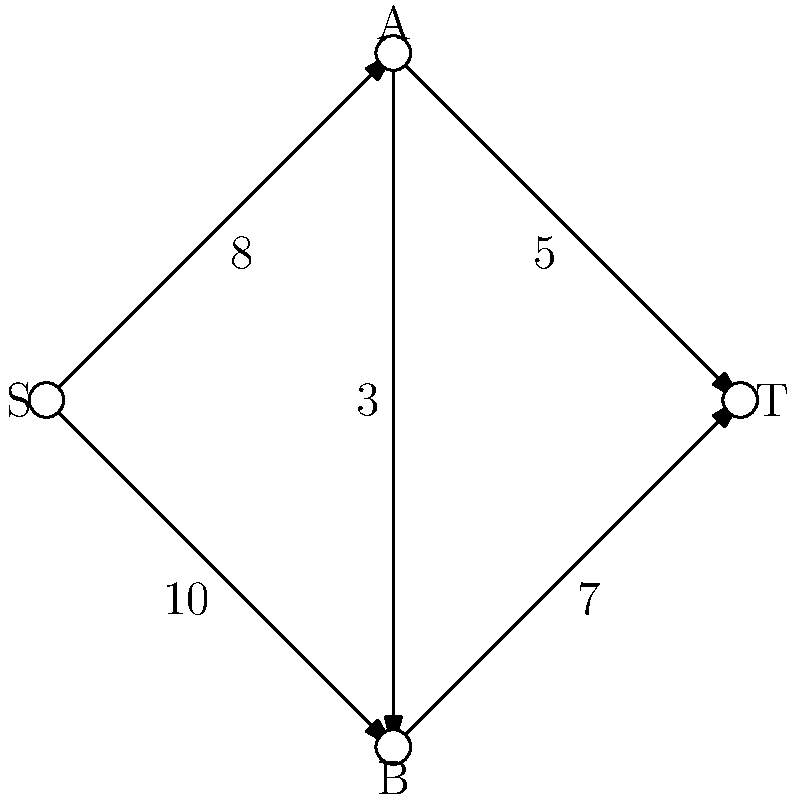In your sustainable fashion production process, you want to minimize waste by optimizing the flow of materials through different stages. The flow network above represents the production stages, where S is the source (raw materials), T is the sink (final products), and A and B are intermediate processing stages. The numbers on the edges represent the maximum capacity of materials that can be processed between stages. What is the maximum flow of materials from S to T, representing the most efficient use of resources with minimal waste? To solve this problem, we'll use the Ford-Fulkerson algorithm to find the maximum flow in the network:

1. Start with zero flow on all edges.

2. Find an augmenting path from S to T:
   Path 1: S → A → T (min capacity: 5)
   Augment flow: 5
   Residual capacities: S→A: 3, A→T: 0

3. Find another augmenting path:
   Path 2: S → B → T (min capacity: 7)
   Augment flow: 7
   Residual capacities: S→B: 3, B→T: 0

4. Find another augmenting path:
   Path 3: S → A → B → T (min capacity: 3)
   Augment flow: 3
   Residual capacities: S→A: 0, A→B: 0, B→T: 0

5. No more augmenting paths exist, so the algorithm terminates.

6. Calculate total flow:
   Flow through Path 1: 5
   Flow through Path 2: 7
   Flow through Path 3: 3
   Total flow = 5 + 7 + 3 = 15

Therefore, the maximum flow from S to T is 15 units of material.
Answer: 15 units 